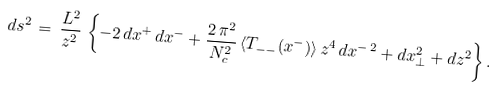<formula> <loc_0><loc_0><loc_500><loc_500>d s ^ { 2 } \, = \, \frac { L ^ { 2 } } { z ^ { 2 } } \, \left \{ - 2 \, d x ^ { + } \, d x ^ { - } + \frac { 2 \, \pi ^ { 2 } } { N _ { c } ^ { 2 } } \, \langle T _ { - - } ( x ^ { - } ) \rangle \, z ^ { 4 } \, d x ^ { - \, 2 } + d x _ { \perp } ^ { 2 } + d z ^ { 2 } \right \} .</formula> 